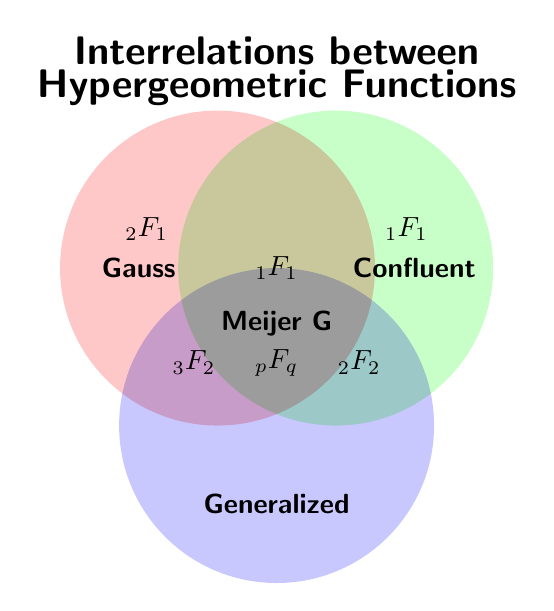What functions intersect between the Gauss and Generalized categories? The intersection between Gauss and Generalized categories is denoted in the figure as \( 3F2 \). This symbol is placed at the overlap section between the Gauss and Generalized circles.
Answer: \( 3F2 \) Which function is common across Gauss, Confluent, and Generalized categories? The function common across all three categories is denoted by \( \text{Meijer G} \). This label is present at the intersection of the three circles where all the areas overlap.
Answer: Meijer G What distinct function belongs only to the Gauss category? The function that exclusively belongs to the Gauss category is \( 2F1 \). This symbol is positioned within the Gauss circle and outside any overlap with other circles.
Answer: \( 2F1 \) Which functions are present in the Confluent category? The functions in the Confluent category include \( 1F1 \) and \( 2F2 \). The \( 1F1 \) symbol appears both inside the Confluent circle alone and in overlapping regions with other circles, whereas \( 2F2 \) is found in the intersection between Confluent and Generalized.
Answer: \( 1F1 \) and \( 2F2 \) How many functions directly belong to only one category? By counting the functions that are placed within non-overlapping sections of each circle, we find \( 2F1 \) for Gauss, \( 1F1 \) for Confluent, and \( pFq \) for Generalized. This results in three functions.
Answer: 3 Which functions are shared between the Confluent and Generalized categories but not with Gauss? The only function that fits this description is \( 2F2 \), which is placed at the overlapping section of Confluent and Generalized circles, excluding any intersection with the Gauss circle.
Answer: \( 2F2 \) If a new function is identified to fit into both Gauss and Confluent categories, where should it be placed on the Venn diagram? The new function would need to be placed in the overlapping region between the Gauss and Confluent circles, without encroaching on the overlapping areas with the Generalized circle. This is where \( 1F1 \) has been positioned.
Answer: Intersection of Gauss and Confluent circles Does the function \( 1F1 \) belong to more than one category? Yes, \( 1F1 \) is shared between the Gauss and Confluent categories as shown by its position in the overlapping region of these two circles.
Answer: Yes 